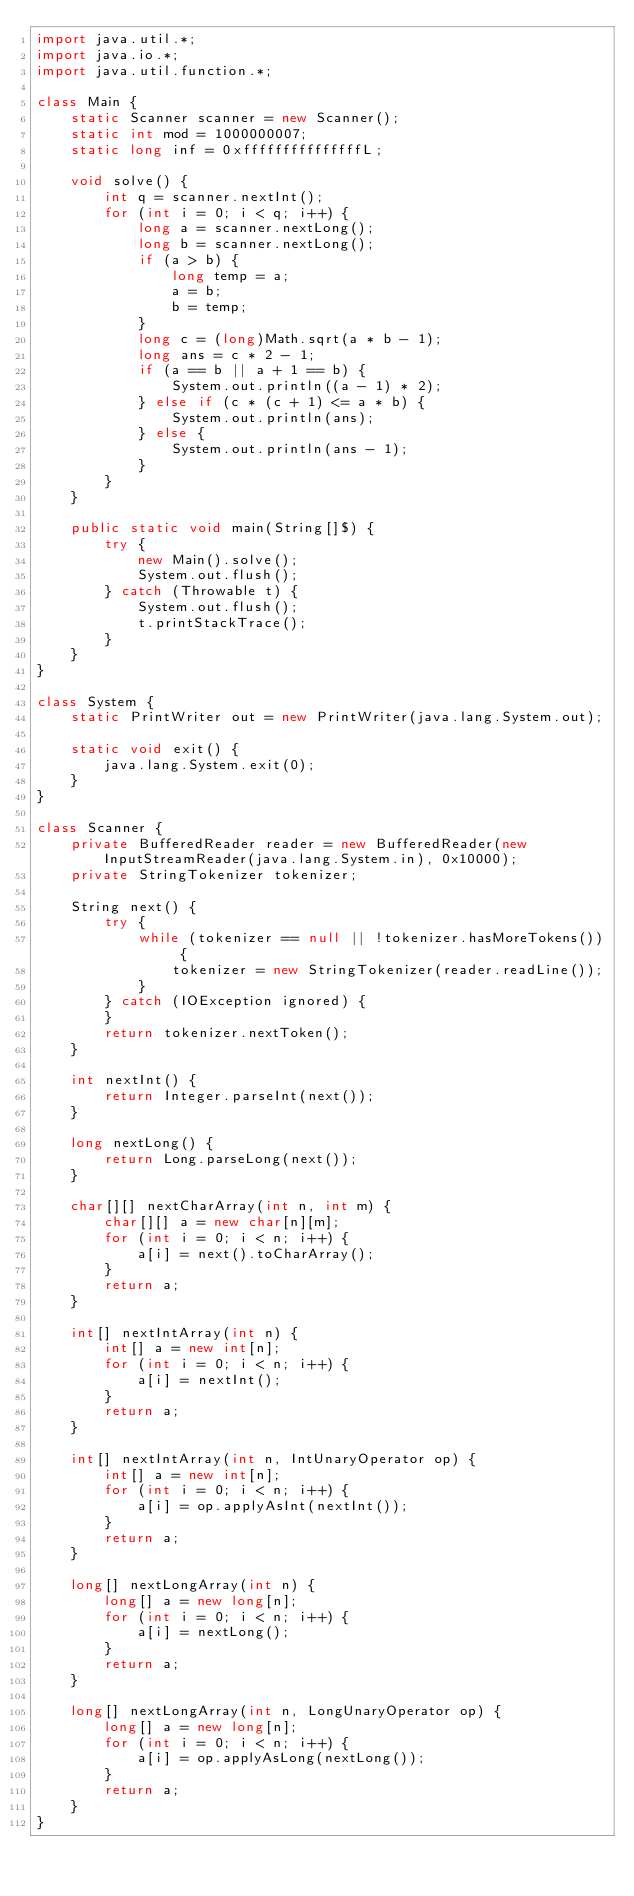<code> <loc_0><loc_0><loc_500><loc_500><_Java_>import java.util.*;
import java.io.*;
import java.util.function.*;

class Main {
    static Scanner scanner = new Scanner();
    static int mod = 1000000007;
    static long inf = 0xfffffffffffffffL;

    void solve() {
        int q = scanner.nextInt();
        for (int i = 0; i < q; i++) {
            long a = scanner.nextLong();
            long b = scanner.nextLong();
            if (a > b) {
                long temp = a;
                a = b;
                b = temp;
            }
            long c = (long)Math.sqrt(a * b - 1);
            long ans = c * 2 - 1;
            if (a == b || a + 1 == b) {
                System.out.println((a - 1) * 2);
            } else if (c * (c + 1) <= a * b) {
                System.out.println(ans);
            } else {
                System.out.println(ans - 1);
            }
        }
    }

    public static void main(String[]$) {
        try {
            new Main().solve();
            System.out.flush();
        } catch (Throwable t) {
            System.out.flush();
            t.printStackTrace();
        }
    }
}

class System {
    static PrintWriter out = new PrintWriter(java.lang.System.out);

    static void exit() {
        java.lang.System.exit(0);
    }
}

class Scanner {
    private BufferedReader reader = new BufferedReader(new InputStreamReader(java.lang.System.in), 0x10000);
    private StringTokenizer tokenizer;

    String next() {
        try {
            while (tokenizer == null || !tokenizer.hasMoreTokens()) {
                tokenizer = new StringTokenizer(reader.readLine());
            }
        } catch (IOException ignored) {
        }
        return tokenizer.nextToken();
    }

    int nextInt() {
        return Integer.parseInt(next());
    }

    long nextLong() {
        return Long.parseLong(next());
    }

    char[][] nextCharArray(int n, int m) {
        char[][] a = new char[n][m];
        for (int i = 0; i < n; i++) {
            a[i] = next().toCharArray();
        }
        return a;
    }

    int[] nextIntArray(int n) {
        int[] a = new int[n];
        for (int i = 0; i < n; i++) {
            a[i] = nextInt();
        }
        return a;
    }

    int[] nextIntArray(int n, IntUnaryOperator op) {
        int[] a = new int[n];
        for (int i = 0; i < n; i++) {
            a[i] = op.applyAsInt(nextInt());
        }
        return a;
    }

    long[] nextLongArray(int n) {
        long[] a = new long[n];
        for (int i = 0; i < n; i++) {
            a[i] = nextLong();
        }
        return a;
    }

    long[] nextLongArray(int n, LongUnaryOperator op) {
        long[] a = new long[n];
        for (int i = 0; i < n; i++) {
            a[i] = op.applyAsLong(nextLong());
        }
        return a;
    }
}
</code> 